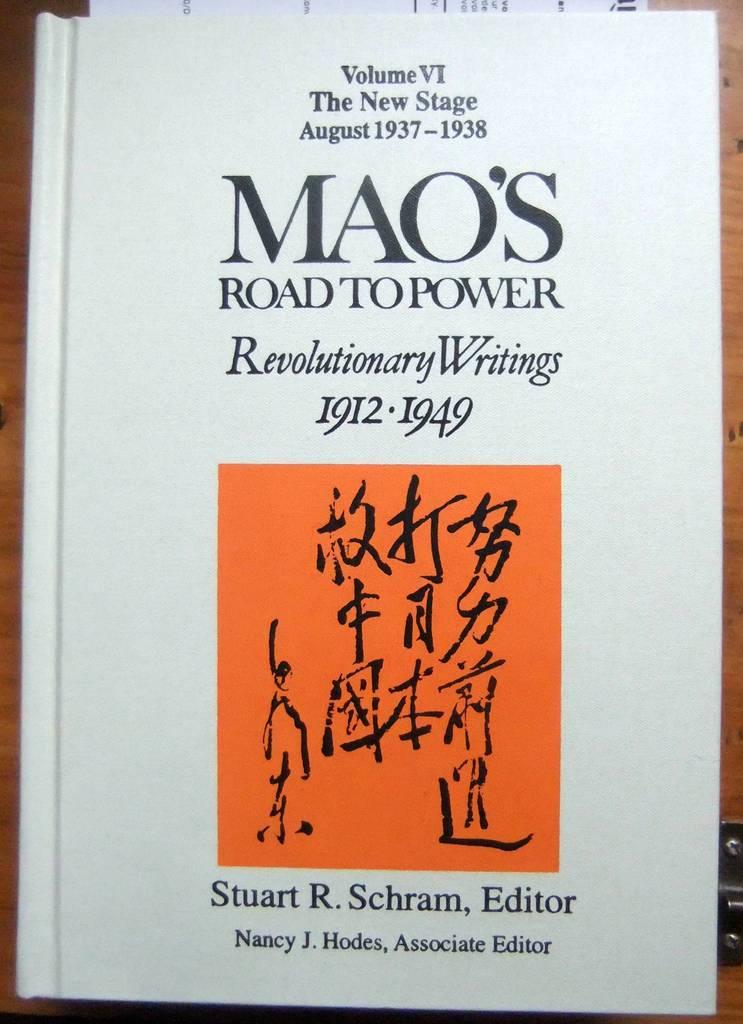What is present in the image that can be written on? There is a paper in the image that can be written on. What can be found on the paper in the image? There is text written on the paper in the image. What is the tendency of the neck in the image? There is no neck present in the image. 